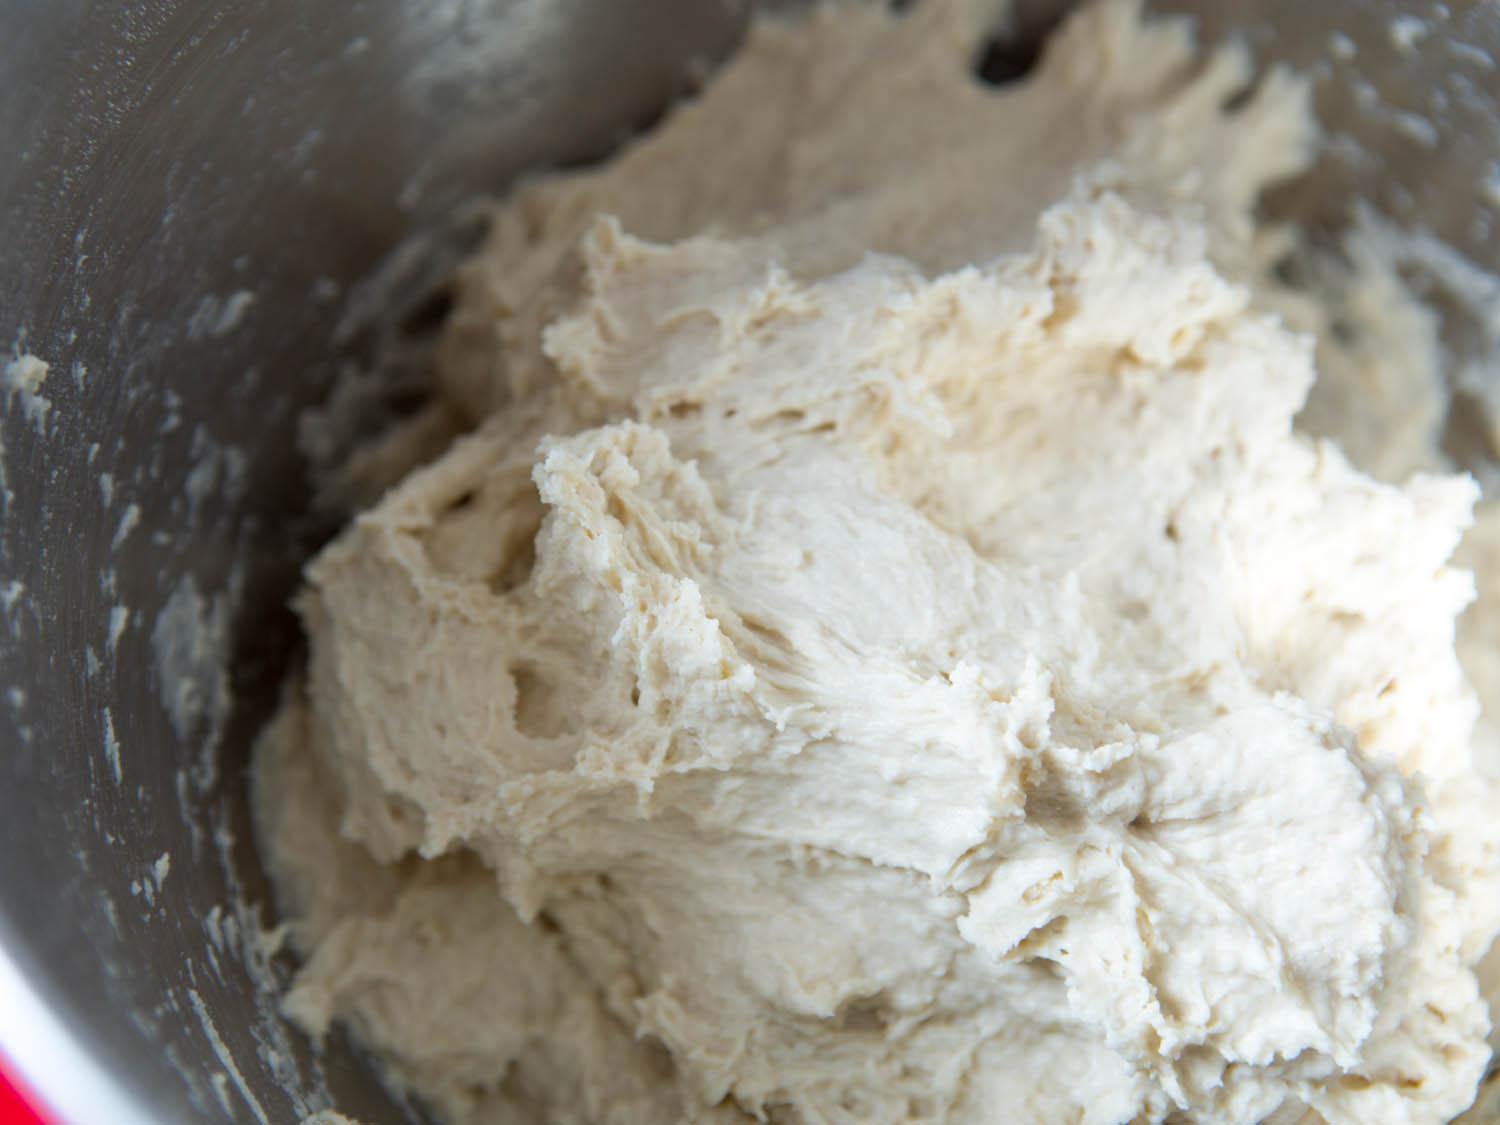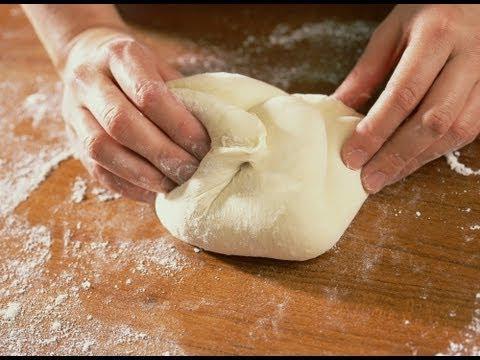The first image is the image on the left, the second image is the image on the right. Given the left and right images, does the statement "One of the images shows a pair of hands kneading dough and the other image shows a ball of dough in a bowl." hold true? Answer yes or no. Yes. The first image is the image on the left, the second image is the image on the right. For the images shown, is this caption "Exactly one ball of dough is on a table." true? Answer yes or no. Yes. 